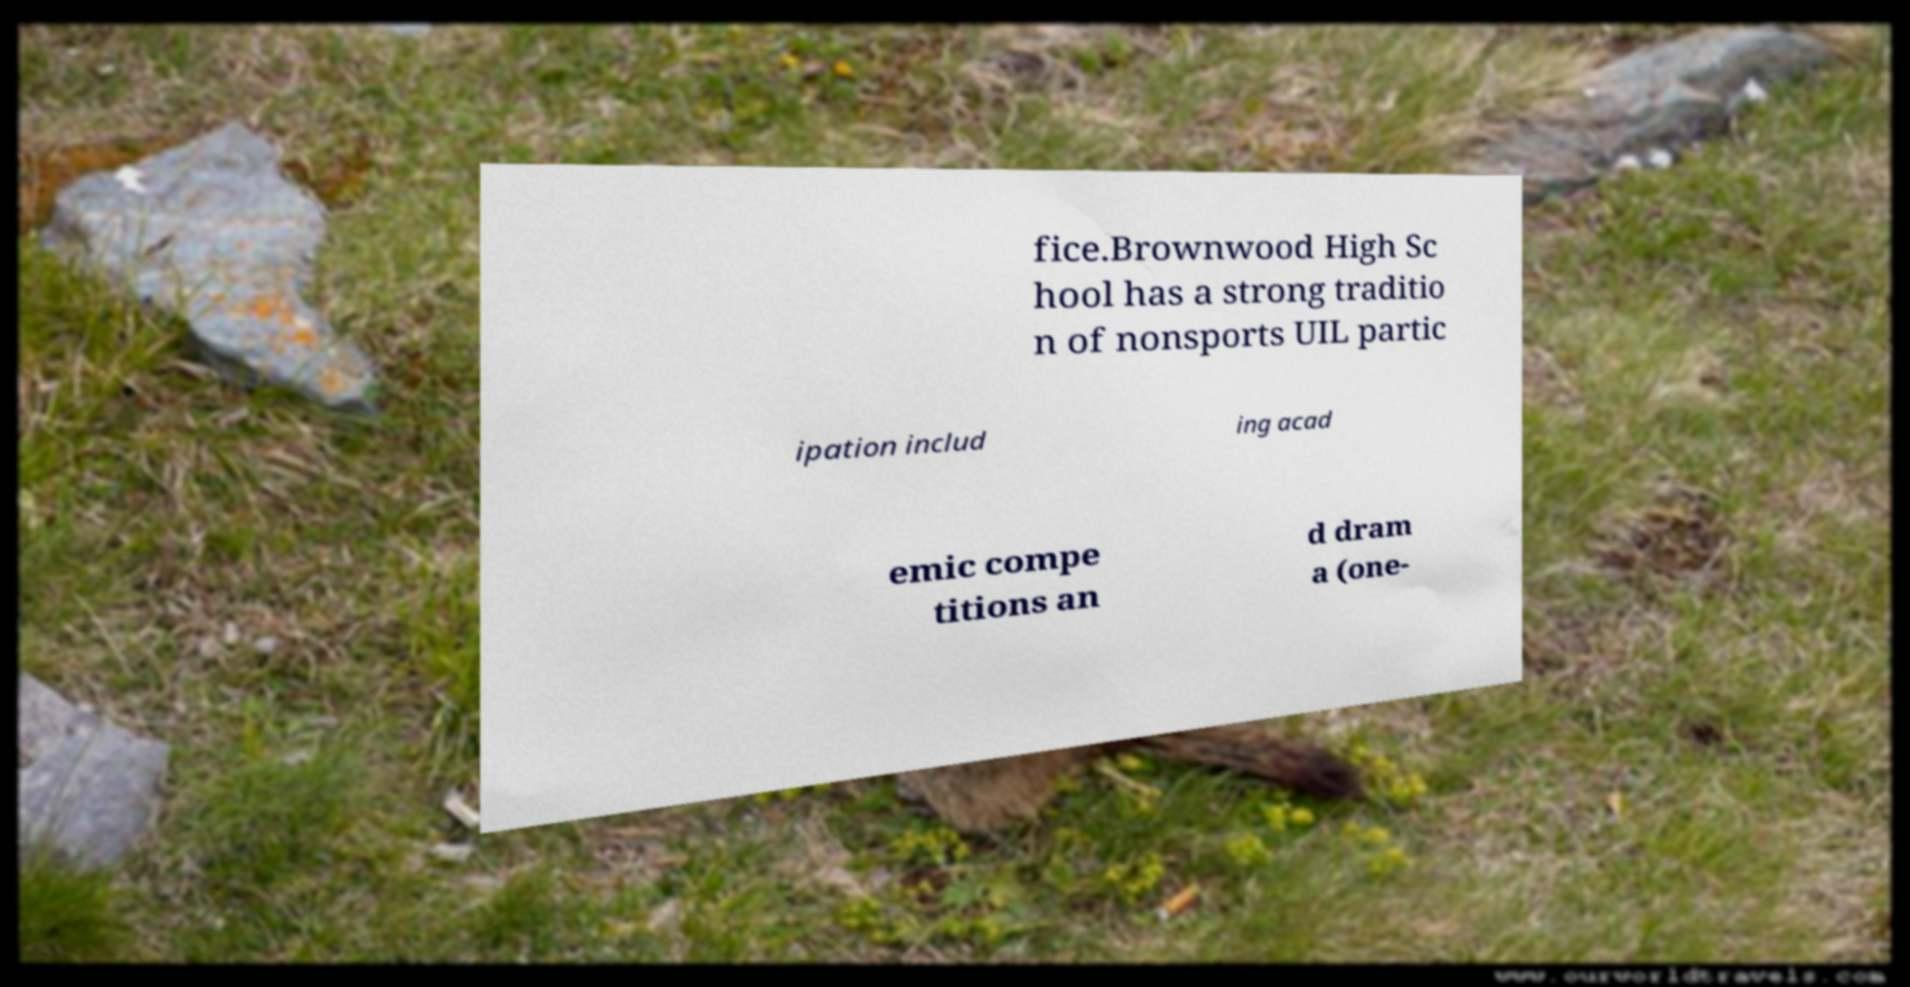Please identify and transcribe the text found in this image. fice.Brownwood High Sc hool has a strong traditio n of nonsports UIL partic ipation includ ing acad emic compe titions an d dram a (one- 